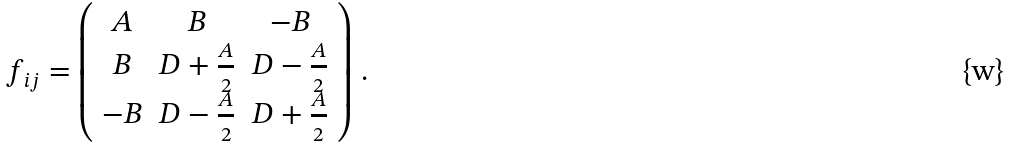<formula> <loc_0><loc_0><loc_500><loc_500>f _ { i j } = \left ( \begin{array} { c c c } A & B & - B \\ B & D + \frac { A } { 2 } & D - \frac { A } { 2 } \\ - B & D - \frac { A } { 2 } & D + \frac { A } { 2 } \end{array} \right ) \, .</formula> 